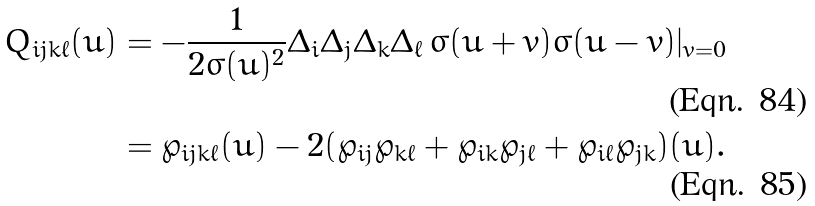Convert formula to latex. <formula><loc_0><loc_0><loc_500><loc_500>Q _ { i j k \ell } ( u ) & = - \frac { 1 } { 2 \sigma ( u ) ^ { 2 } } \Delta _ { i } \Delta _ { j } \Delta _ { k } \Delta _ { \ell } \, \sigma ( u + v ) \sigma ( u - v ) | _ { v = 0 } \\ & = \wp _ { i j k \ell } ( u ) - 2 ( \wp _ { i j } \wp _ { k \ell } + \wp _ { i k } \wp _ { j \ell } + \wp _ { i \ell } \wp _ { j k } ) ( u ) .</formula> 